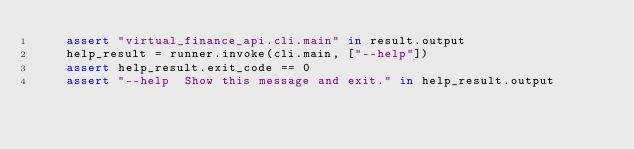Convert code to text. <code><loc_0><loc_0><loc_500><loc_500><_Python_>    assert "virtual_finance_api.cli.main" in result.output
    help_result = runner.invoke(cli.main, ["--help"])
    assert help_result.exit_code == 0
    assert "--help  Show this message and exit." in help_result.output
</code> 